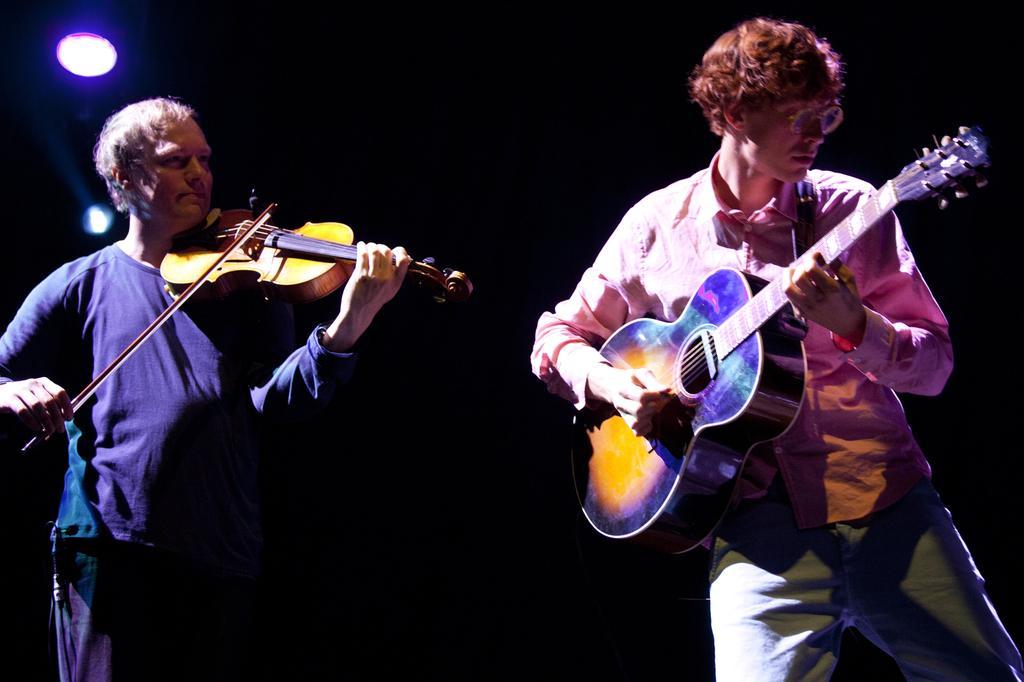Can you describe this image briefly? this picture shows two men standing holding musical instruments a man playing guitar and a man playing violin 